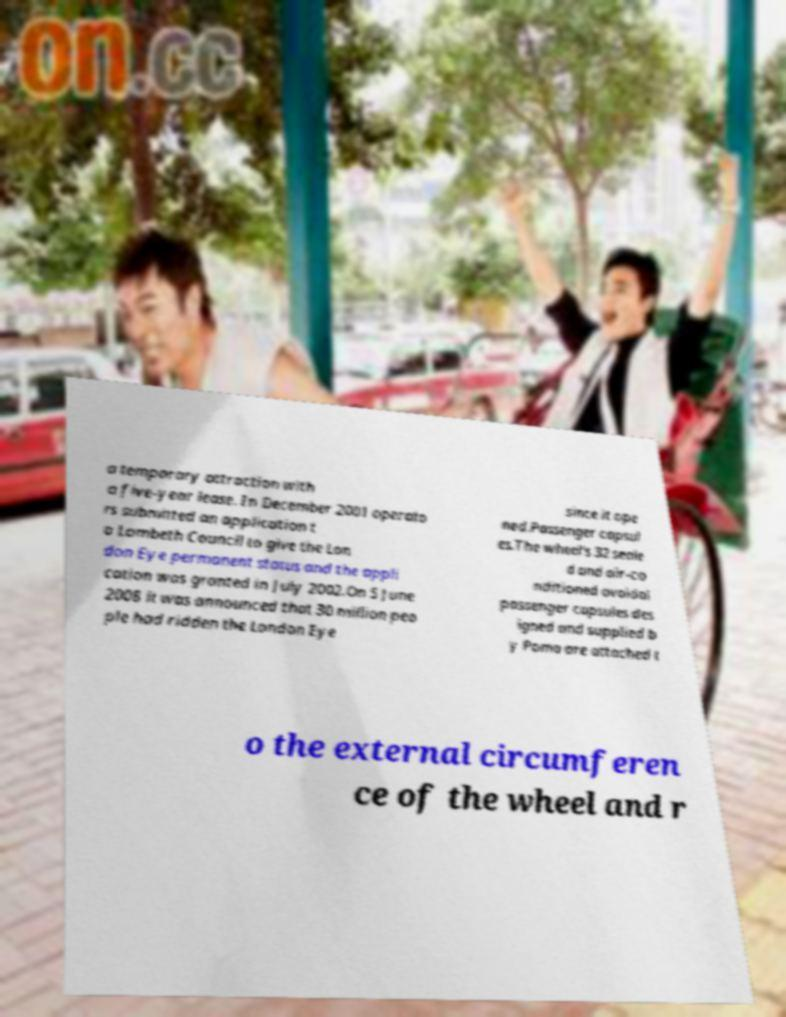Could you assist in decoding the text presented in this image and type it out clearly? a temporary attraction with a five-year lease. In December 2001 operato rs submitted an application t o Lambeth Council to give the Lon don Eye permanent status and the appli cation was granted in July 2002.On 5 June 2008 it was announced that 30 million peo ple had ridden the London Eye since it ope ned.Passenger capsul es.The wheel's 32 seale d and air-co nditioned ovoidal passenger capsules des igned and supplied b y Poma are attached t o the external circumferen ce of the wheel and r 